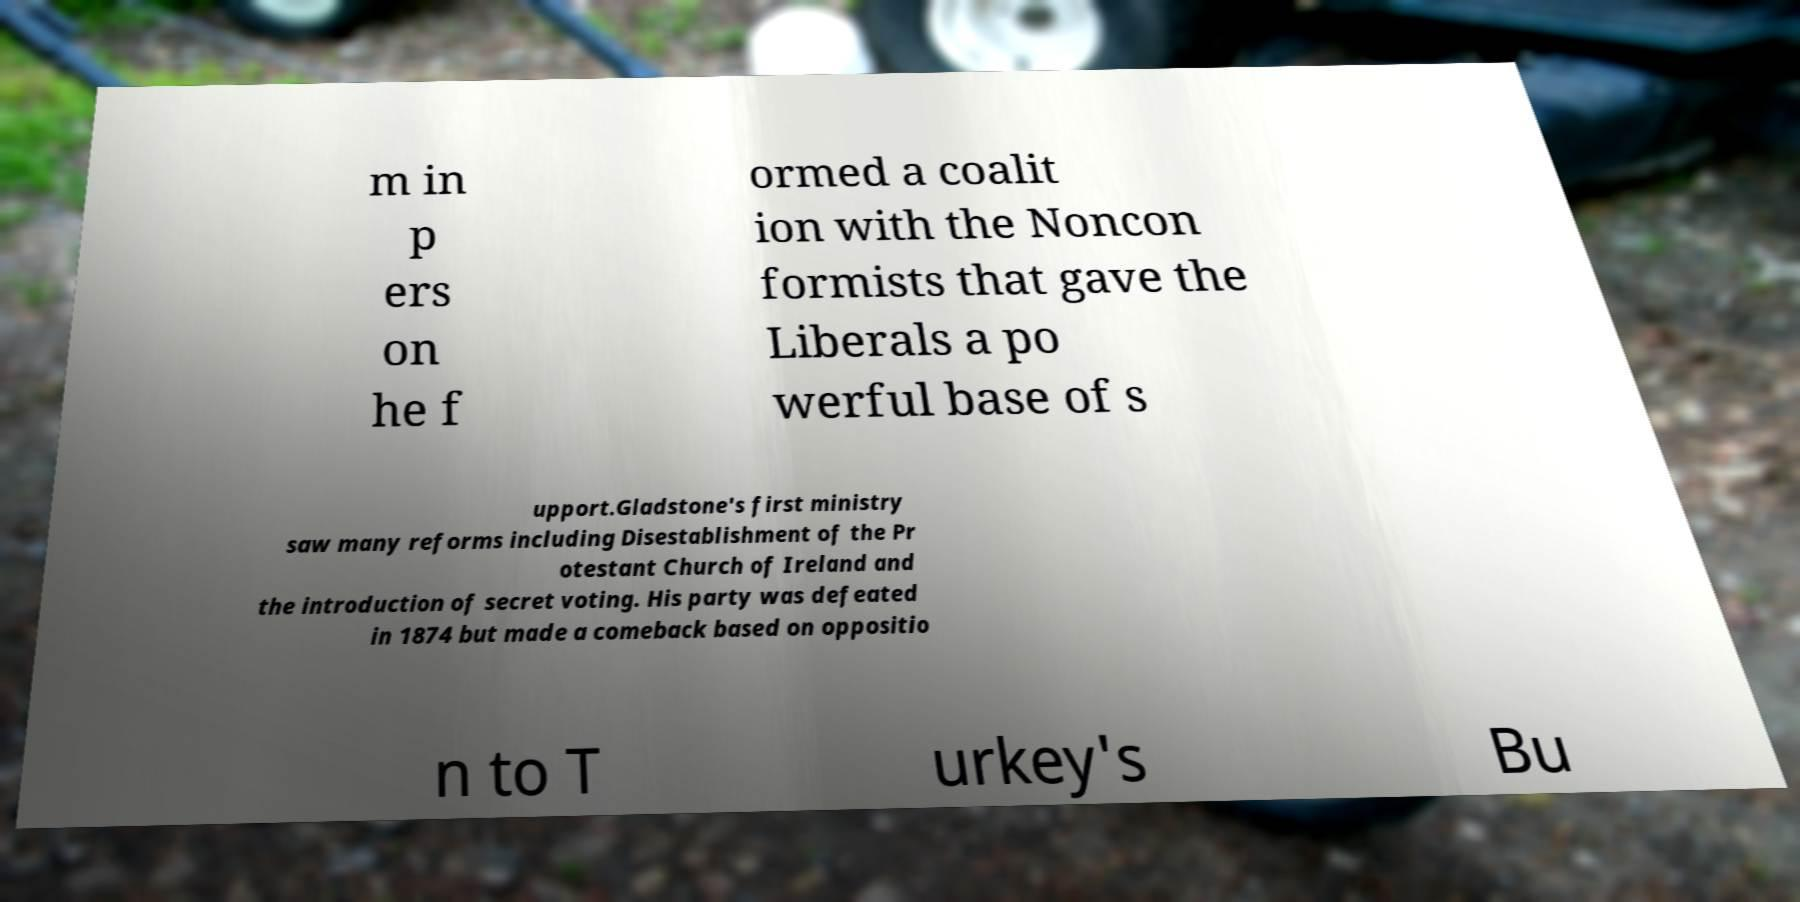Can you accurately transcribe the text from the provided image for me? m in p ers on he f ormed a coalit ion with the Noncon formists that gave the Liberals a po werful base of s upport.Gladstone's first ministry saw many reforms including Disestablishment of the Pr otestant Church of Ireland and the introduction of secret voting. His party was defeated in 1874 but made a comeback based on oppositio n to T urkey's Bu 